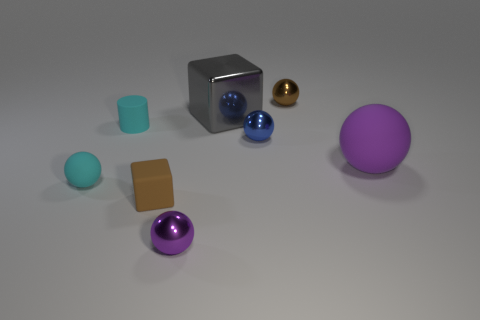Do the small object that is behind the cylinder and the blue object have the same material?
Offer a very short reply. Yes. There is another rubber object that is the same shape as the big purple matte thing; what is its color?
Provide a short and direct response. Cyan. Are there the same number of spheres that are right of the cyan rubber cylinder and matte things?
Your response must be concise. Yes. Are there any gray cubes in front of the tiny purple metallic sphere?
Your answer should be compact. No. There is a gray thing behind the purple thing that is right of the small brown thing on the right side of the tiny blue thing; how big is it?
Provide a short and direct response. Large. Do the brown object behind the big matte thing and the small cyan object in front of the big purple matte thing have the same shape?
Ensure brevity in your answer.  Yes. What size is the purple rubber object that is the same shape as the purple metallic object?
Offer a very short reply. Large. How many spheres have the same material as the big gray object?
Provide a succinct answer. 3. What is the material of the blue ball?
Provide a short and direct response. Metal. What shape is the brown thing that is left of the tiny metal ball that is to the left of the big gray object?
Provide a succinct answer. Cube. 